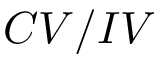<formula> <loc_0><loc_0><loc_500><loc_500>C V / I V</formula> 